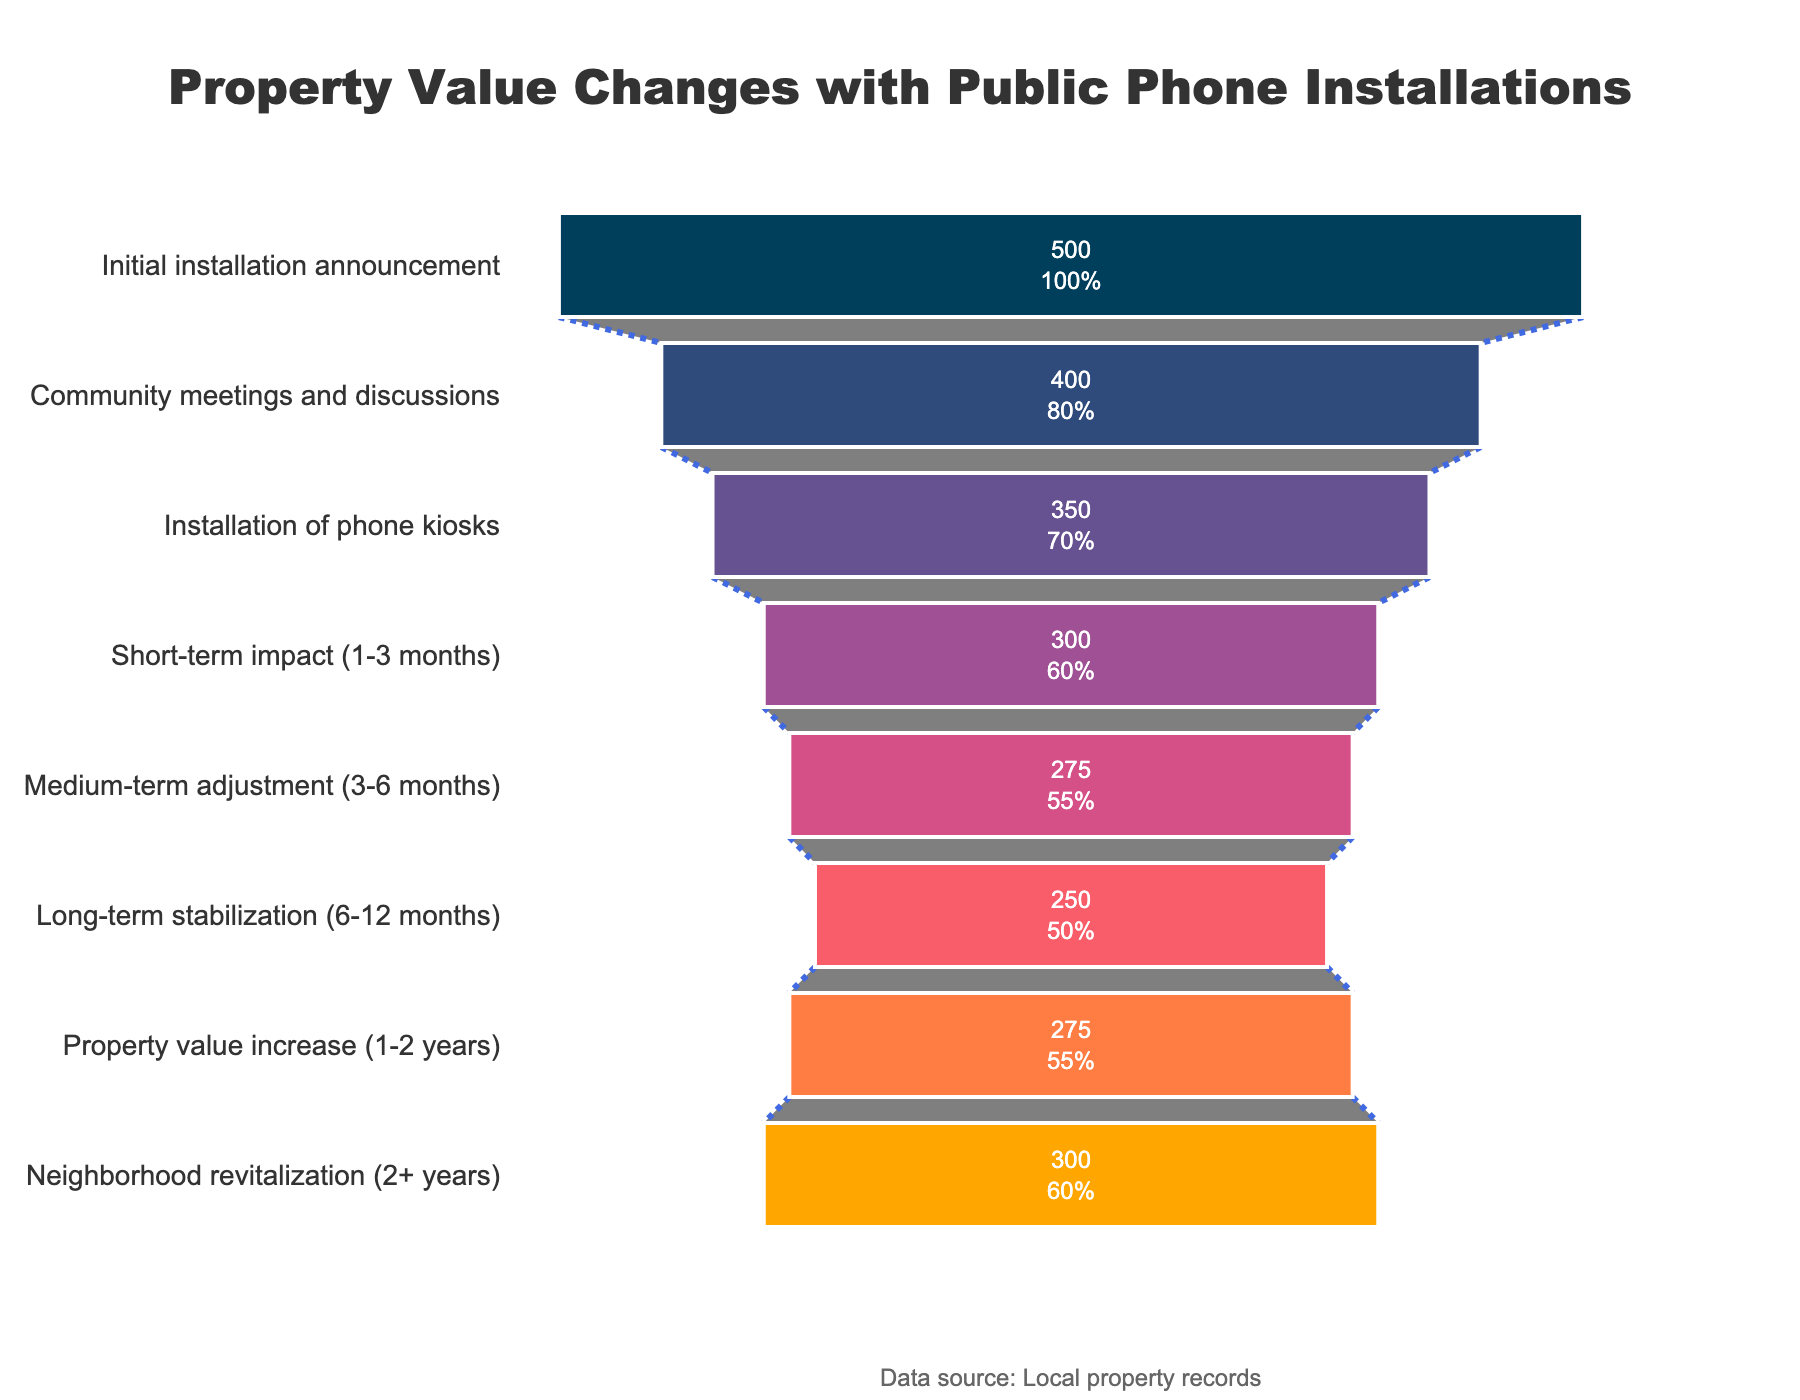What phase of property value change had the highest number of properties? To find the phase with the highest number of properties, I will look at the values associated with each phase. The highest value is 500 during the "Initial installation announcement" phase.
Answer: Initial installation announcement How many properties were affected in the "Short-term impact (1-3 months)" phase? I will locate the "Short-term impact (1-3 months)" phase on the funnel chart and read the corresponding number of properties, which is 300.
Answer: 300 What is the difference in the number of properties between the "Installation of phone kiosks" phase and the "Medium-term adjustment (3-6 months)" phase? To find the difference, I will subtract the number of properties in the "Medium-term adjustment" phase (275) from the "Installation of phone kiosks" phase (350). The calculation is 350 - 275 = 75.
Answer: 75 Which phase shows an increase in the number of properties compared to the previous phase? I will look at each phase in sequence to see where the number increases compared to the previous phase. The "Property value increase (1-2 years)" phase increased by 25 compared to the "Long-term stabilization (6-12 months)" phase (250 to 275).
Answer: Property value increase (1-2 years) What's the average number of properties affected in the phases before the "Installation of phone kiosks"? To calculate the average, I will add the number of properties in the phases before "Installation of phone kiosks" (500 + 400) and divide by the number of these phases (2). The calculation is (500 + 400)/2 = 450.
Answer: 450 Is the number of properties in the "Neighborhood revitalization (2+ years)" phase higher or lower than in the "Medium-term adjustment (3-6 months)" phase? I will compare the number of properties in the "Neighborhood revitalization" phase (300) with the "Medium-term adjustment" phase (275). Since 300 is greater than 275, the number is higher.
Answer: Higher How many phases show a decrease in the number of properties compared to the previous phase? To determine this, I will count the phases where the number of properties decreases compared to the previous one. These are "Community meetings and discussions" (400), "Installation of phone kiosks" (350), "Short-term impact (1-3 months)" (300), "Medium-term adjustment (3-6 months)" (275), and "Long-term stabilization (6-12 months)" (250). There are five phases with decreasing numbers.
Answer: 5 What's the trend in property values after the "Long-term stabilization (6-12 months)" phase? To determine the trend, I will look at the values in the phases following "Long-term stabilization." These are "Property value increase (1-2 years)" (275) and "Neighborhood revitalization (2+ years)" (300). It shows an increasing trend.
Answer: Increasing What percentage of properties were affected in the "Community meetings and discussions" phase relative to the "Initial installation announcement" phase? To find the percentage, I will divide the number of properties in the "Community meetings and discussions" phase (400) by the "Initial installation announcement" phase (500) and multiply by 100. The calculation is (400/500) * 100 = 80%.
Answer: 80% What's the cumulative number of properties affected by the end of "Medium-term adjustment (3-6 months)" phase? To find the cumulative number, I will add up the properties from each phase up to and including "Medium-term adjustment." The phases are "Initial installation announcement" (500), "Community meetings and discussions" (400), "Installation of phone kiosks" (350), "Short-term impact (300)" and "Medium-term adjustment (275)." The calculation is 500 + 400 + 350 + 300 + 275 = 1825.
Answer: 1825 